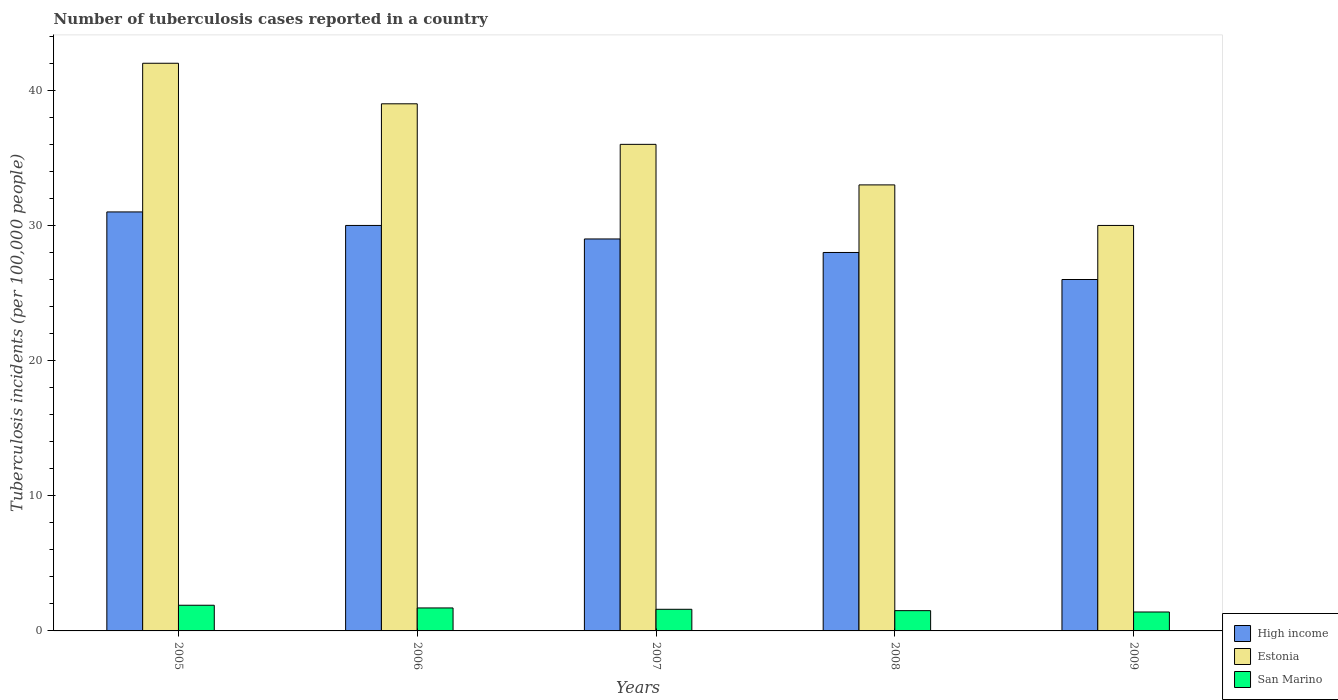How many different coloured bars are there?
Provide a succinct answer. 3. Are the number of bars per tick equal to the number of legend labels?
Give a very brief answer. Yes. How many bars are there on the 5th tick from the left?
Offer a terse response. 3. In how many cases, is the number of bars for a given year not equal to the number of legend labels?
Ensure brevity in your answer.  0. What is the number of tuberculosis cases reported in in Estonia in 2006?
Your response must be concise. 39. Across all years, what is the maximum number of tuberculosis cases reported in in Estonia?
Your answer should be compact. 42. In which year was the number of tuberculosis cases reported in in High income minimum?
Your response must be concise. 2009. What is the total number of tuberculosis cases reported in in San Marino in the graph?
Your response must be concise. 8.1. What is the difference between the number of tuberculosis cases reported in in San Marino in 2006 and that in 2007?
Ensure brevity in your answer.  0.1. What is the difference between the number of tuberculosis cases reported in in High income in 2005 and the number of tuberculosis cases reported in in Estonia in 2009?
Give a very brief answer. 1. What is the average number of tuberculosis cases reported in in Estonia per year?
Ensure brevity in your answer.  36. In the year 2009, what is the difference between the number of tuberculosis cases reported in in Estonia and number of tuberculosis cases reported in in San Marino?
Your answer should be very brief. 28.6. What is the ratio of the number of tuberculosis cases reported in in High income in 2007 to that in 2008?
Offer a very short reply. 1.04. What is the difference between the highest and the second highest number of tuberculosis cases reported in in San Marino?
Provide a short and direct response. 0.2. What is the difference between the highest and the lowest number of tuberculosis cases reported in in Estonia?
Ensure brevity in your answer.  12. In how many years, is the number of tuberculosis cases reported in in San Marino greater than the average number of tuberculosis cases reported in in San Marino taken over all years?
Offer a terse response. 2. What does the 3rd bar from the right in 2005 represents?
Offer a terse response. High income. How many years are there in the graph?
Ensure brevity in your answer.  5. What is the difference between two consecutive major ticks on the Y-axis?
Your answer should be compact. 10. Are the values on the major ticks of Y-axis written in scientific E-notation?
Offer a terse response. No. Does the graph contain grids?
Provide a succinct answer. No. Where does the legend appear in the graph?
Ensure brevity in your answer.  Bottom right. How are the legend labels stacked?
Your response must be concise. Vertical. What is the title of the graph?
Provide a succinct answer. Number of tuberculosis cases reported in a country. Does "Syrian Arab Republic" appear as one of the legend labels in the graph?
Provide a short and direct response. No. What is the label or title of the Y-axis?
Offer a terse response. Tuberculosis incidents (per 100,0 people). What is the Tuberculosis incidents (per 100,000 people) of High income in 2006?
Offer a terse response. 30. What is the Tuberculosis incidents (per 100,000 people) of Estonia in 2006?
Your answer should be compact. 39. What is the Tuberculosis incidents (per 100,000 people) of San Marino in 2006?
Ensure brevity in your answer.  1.7. What is the Tuberculosis incidents (per 100,000 people) of High income in 2007?
Ensure brevity in your answer.  29. What is the Tuberculosis incidents (per 100,000 people) in Estonia in 2007?
Ensure brevity in your answer.  36. What is the Tuberculosis incidents (per 100,000 people) of San Marino in 2007?
Provide a short and direct response. 1.6. What is the Tuberculosis incidents (per 100,000 people) of High income in 2008?
Your response must be concise. 28. What is the Tuberculosis incidents (per 100,000 people) in Estonia in 2008?
Keep it short and to the point. 33. What is the Tuberculosis incidents (per 100,000 people) of High income in 2009?
Provide a succinct answer. 26. What is the Tuberculosis incidents (per 100,000 people) in Estonia in 2009?
Keep it short and to the point. 30. What is the Tuberculosis incidents (per 100,000 people) in San Marino in 2009?
Give a very brief answer. 1.4. Across all years, what is the maximum Tuberculosis incidents (per 100,000 people) of Estonia?
Provide a short and direct response. 42. Across all years, what is the maximum Tuberculosis incidents (per 100,000 people) of San Marino?
Offer a very short reply. 1.9. Across all years, what is the minimum Tuberculosis incidents (per 100,000 people) in High income?
Your answer should be compact. 26. What is the total Tuberculosis incidents (per 100,000 people) of High income in the graph?
Your response must be concise. 144. What is the total Tuberculosis incidents (per 100,000 people) in Estonia in the graph?
Provide a succinct answer. 180. What is the difference between the Tuberculosis incidents (per 100,000 people) of San Marino in 2005 and that in 2006?
Keep it short and to the point. 0.2. What is the difference between the Tuberculosis incidents (per 100,000 people) of Estonia in 2005 and that in 2007?
Your answer should be compact. 6. What is the difference between the Tuberculosis incidents (per 100,000 people) in San Marino in 2005 and that in 2007?
Keep it short and to the point. 0.3. What is the difference between the Tuberculosis incidents (per 100,000 people) in High income in 2005 and that in 2008?
Offer a terse response. 3. What is the difference between the Tuberculosis incidents (per 100,000 people) in High income in 2006 and that in 2007?
Ensure brevity in your answer.  1. What is the difference between the Tuberculosis incidents (per 100,000 people) in Estonia in 2006 and that in 2007?
Provide a short and direct response. 3. What is the difference between the Tuberculosis incidents (per 100,000 people) of San Marino in 2006 and that in 2007?
Offer a terse response. 0.1. What is the difference between the Tuberculosis incidents (per 100,000 people) in High income in 2006 and that in 2008?
Provide a succinct answer. 2. What is the difference between the Tuberculosis incidents (per 100,000 people) in High income in 2006 and that in 2009?
Make the answer very short. 4. What is the difference between the Tuberculosis incidents (per 100,000 people) of Estonia in 2006 and that in 2009?
Your answer should be compact. 9. What is the difference between the Tuberculosis incidents (per 100,000 people) in San Marino in 2006 and that in 2009?
Your response must be concise. 0.3. What is the difference between the Tuberculosis incidents (per 100,000 people) in High income in 2007 and that in 2008?
Offer a very short reply. 1. What is the difference between the Tuberculosis incidents (per 100,000 people) in Estonia in 2007 and that in 2008?
Make the answer very short. 3. What is the difference between the Tuberculosis incidents (per 100,000 people) in San Marino in 2007 and that in 2008?
Provide a succinct answer. 0.1. What is the difference between the Tuberculosis incidents (per 100,000 people) in Estonia in 2008 and that in 2009?
Give a very brief answer. 3. What is the difference between the Tuberculosis incidents (per 100,000 people) of High income in 2005 and the Tuberculosis incidents (per 100,000 people) of San Marino in 2006?
Your answer should be very brief. 29.3. What is the difference between the Tuberculosis incidents (per 100,000 people) of Estonia in 2005 and the Tuberculosis incidents (per 100,000 people) of San Marino in 2006?
Offer a terse response. 40.3. What is the difference between the Tuberculosis incidents (per 100,000 people) of High income in 2005 and the Tuberculosis incidents (per 100,000 people) of San Marino in 2007?
Your answer should be very brief. 29.4. What is the difference between the Tuberculosis incidents (per 100,000 people) of Estonia in 2005 and the Tuberculosis incidents (per 100,000 people) of San Marino in 2007?
Your answer should be compact. 40.4. What is the difference between the Tuberculosis incidents (per 100,000 people) in High income in 2005 and the Tuberculosis incidents (per 100,000 people) in San Marino in 2008?
Ensure brevity in your answer.  29.5. What is the difference between the Tuberculosis incidents (per 100,000 people) of Estonia in 2005 and the Tuberculosis incidents (per 100,000 people) of San Marino in 2008?
Keep it short and to the point. 40.5. What is the difference between the Tuberculosis incidents (per 100,000 people) of High income in 2005 and the Tuberculosis incidents (per 100,000 people) of Estonia in 2009?
Offer a very short reply. 1. What is the difference between the Tuberculosis incidents (per 100,000 people) of High income in 2005 and the Tuberculosis incidents (per 100,000 people) of San Marino in 2009?
Offer a very short reply. 29.6. What is the difference between the Tuberculosis incidents (per 100,000 people) in Estonia in 2005 and the Tuberculosis incidents (per 100,000 people) in San Marino in 2009?
Keep it short and to the point. 40.6. What is the difference between the Tuberculosis incidents (per 100,000 people) in High income in 2006 and the Tuberculosis incidents (per 100,000 people) in Estonia in 2007?
Your response must be concise. -6. What is the difference between the Tuberculosis incidents (per 100,000 people) in High income in 2006 and the Tuberculosis incidents (per 100,000 people) in San Marino in 2007?
Give a very brief answer. 28.4. What is the difference between the Tuberculosis incidents (per 100,000 people) of Estonia in 2006 and the Tuberculosis incidents (per 100,000 people) of San Marino in 2007?
Ensure brevity in your answer.  37.4. What is the difference between the Tuberculosis incidents (per 100,000 people) in Estonia in 2006 and the Tuberculosis incidents (per 100,000 people) in San Marino in 2008?
Your answer should be very brief. 37.5. What is the difference between the Tuberculosis incidents (per 100,000 people) in High income in 2006 and the Tuberculosis incidents (per 100,000 people) in San Marino in 2009?
Ensure brevity in your answer.  28.6. What is the difference between the Tuberculosis incidents (per 100,000 people) in Estonia in 2006 and the Tuberculosis incidents (per 100,000 people) in San Marino in 2009?
Your response must be concise. 37.6. What is the difference between the Tuberculosis incidents (per 100,000 people) in High income in 2007 and the Tuberculosis incidents (per 100,000 people) in San Marino in 2008?
Your answer should be compact. 27.5. What is the difference between the Tuberculosis incidents (per 100,000 people) of Estonia in 2007 and the Tuberculosis incidents (per 100,000 people) of San Marino in 2008?
Offer a very short reply. 34.5. What is the difference between the Tuberculosis incidents (per 100,000 people) of High income in 2007 and the Tuberculosis incidents (per 100,000 people) of San Marino in 2009?
Offer a terse response. 27.6. What is the difference between the Tuberculosis incidents (per 100,000 people) in Estonia in 2007 and the Tuberculosis incidents (per 100,000 people) in San Marino in 2009?
Your answer should be very brief. 34.6. What is the difference between the Tuberculosis incidents (per 100,000 people) in High income in 2008 and the Tuberculosis incidents (per 100,000 people) in San Marino in 2009?
Provide a short and direct response. 26.6. What is the difference between the Tuberculosis incidents (per 100,000 people) in Estonia in 2008 and the Tuberculosis incidents (per 100,000 people) in San Marino in 2009?
Ensure brevity in your answer.  31.6. What is the average Tuberculosis incidents (per 100,000 people) in High income per year?
Ensure brevity in your answer.  28.8. What is the average Tuberculosis incidents (per 100,000 people) of Estonia per year?
Provide a succinct answer. 36. What is the average Tuberculosis incidents (per 100,000 people) of San Marino per year?
Your answer should be compact. 1.62. In the year 2005, what is the difference between the Tuberculosis incidents (per 100,000 people) of High income and Tuberculosis incidents (per 100,000 people) of Estonia?
Keep it short and to the point. -11. In the year 2005, what is the difference between the Tuberculosis incidents (per 100,000 people) of High income and Tuberculosis incidents (per 100,000 people) of San Marino?
Your response must be concise. 29.1. In the year 2005, what is the difference between the Tuberculosis incidents (per 100,000 people) in Estonia and Tuberculosis incidents (per 100,000 people) in San Marino?
Your answer should be compact. 40.1. In the year 2006, what is the difference between the Tuberculosis incidents (per 100,000 people) in High income and Tuberculosis incidents (per 100,000 people) in San Marino?
Give a very brief answer. 28.3. In the year 2006, what is the difference between the Tuberculosis incidents (per 100,000 people) in Estonia and Tuberculosis incidents (per 100,000 people) in San Marino?
Your answer should be compact. 37.3. In the year 2007, what is the difference between the Tuberculosis incidents (per 100,000 people) in High income and Tuberculosis incidents (per 100,000 people) in Estonia?
Offer a very short reply. -7. In the year 2007, what is the difference between the Tuberculosis incidents (per 100,000 people) of High income and Tuberculosis incidents (per 100,000 people) of San Marino?
Offer a very short reply. 27.4. In the year 2007, what is the difference between the Tuberculosis incidents (per 100,000 people) in Estonia and Tuberculosis incidents (per 100,000 people) in San Marino?
Your answer should be very brief. 34.4. In the year 2008, what is the difference between the Tuberculosis incidents (per 100,000 people) of Estonia and Tuberculosis incidents (per 100,000 people) of San Marino?
Your answer should be very brief. 31.5. In the year 2009, what is the difference between the Tuberculosis incidents (per 100,000 people) of High income and Tuberculosis incidents (per 100,000 people) of San Marino?
Your answer should be very brief. 24.6. In the year 2009, what is the difference between the Tuberculosis incidents (per 100,000 people) of Estonia and Tuberculosis incidents (per 100,000 people) of San Marino?
Give a very brief answer. 28.6. What is the ratio of the Tuberculosis incidents (per 100,000 people) in High income in 2005 to that in 2006?
Provide a succinct answer. 1.03. What is the ratio of the Tuberculosis incidents (per 100,000 people) in San Marino in 2005 to that in 2006?
Your answer should be compact. 1.12. What is the ratio of the Tuberculosis incidents (per 100,000 people) in High income in 2005 to that in 2007?
Offer a terse response. 1.07. What is the ratio of the Tuberculosis incidents (per 100,000 people) in Estonia in 2005 to that in 2007?
Provide a succinct answer. 1.17. What is the ratio of the Tuberculosis incidents (per 100,000 people) in San Marino in 2005 to that in 2007?
Make the answer very short. 1.19. What is the ratio of the Tuberculosis incidents (per 100,000 people) of High income in 2005 to that in 2008?
Ensure brevity in your answer.  1.11. What is the ratio of the Tuberculosis incidents (per 100,000 people) of Estonia in 2005 to that in 2008?
Your response must be concise. 1.27. What is the ratio of the Tuberculosis incidents (per 100,000 people) in San Marino in 2005 to that in 2008?
Provide a short and direct response. 1.27. What is the ratio of the Tuberculosis incidents (per 100,000 people) of High income in 2005 to that in 2009?
Your answer should be compact. 1.19. What is the ratio of the Tuberculosis incidents (per 100,000 people) of Estonia in 2005 to that in 2009?
Make the answer very short. 1.4. What is the ratio of the Tuberculosis incidents (per 100,000 people) in San Marino in 2005 to that in 2009?
Give a very brief answer. 1.36. What is the ratio of the Tuberculosis incidents (per 100,000 people) in High income in 2006 to that in 2007?
Your answer should be very brief. 1.03. What is the ratio of the Tuberculosis incidents (per 100,000 people) in High income in 2006 to that in 2008?
Your answer should be compact. 1.07. What is the ratio of the Tuberculosis incidents (per 100,000 people) in Estonia in 2006 to that in 2008?
Provide a succinct answer. 1.18. What is the ratio of the Tuberculosis incidents (per 100,000 people) in San Marino in 2006 to that in 2008?
Your response must be concise. 1.13. What is the ratio of the Tuberculosis incidents (per 100,000 people) of High income in 2006 to that in 2009?
Keep it short and to the point. 1.15. What is the ratio of the Tuberculosis incidents (per 100,000 people) of Estonia in 2006 to that in 2009?
Give a very brief answer. 1.3. What is the ratio of the Tuberculosis incidents (per 100,000 people) in San Marino in 2006 to that in 2009?
Make the answer very short. 1.21. What is the ratio of the Tuberculosis incidents (per 100,000 people) of High income in 2007 to that in 2008?
Make the answer very short. 1.04. What is the ratio of the Tuberculosis incidents (per 100,000 people) in San Marino in 2007 to that in 2008?
Provide a succinct answer. 1.07. What is the ratio of the Tuberculosis incidents (per 100,000 people) in High income in 2007 to that in 2009?
Offer a terse response. 1.12. What is the ratio of the Tuberculosis incidents (per 100,000 people) in San Marino in 2007 to that in 2009?
Keep it short and to the point. 1.14. What is the ratio of the Tuberculosis incidents (per 100,000 people) in High income in 2008 to that in 2009?
Provide a short and direct response. 1.08. What is the ratio of the Tuberculosis incidents (per 100,000 people) of San Marino in 2008 to that in 2009?
Offer a terse response. 1.07. What is the difference between the highest and the second highest Tuberculosis incidents (per 100,000 people) of High income?
Your answer should be compact. 1. What is the difference between the highest and the second highest Tuberculosis incidents (per 100,000 people) of Estonia?
Provide a short and direct response. 3. What is the difference between the highest and the lowest Tuberculosis incidents (per 100,000 people) of San Marino?
Keep it short and to the point. 0.5. 